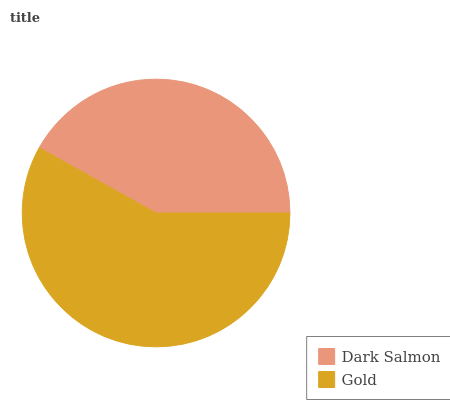Is Dark Salmon the minimum?
Answer yes or no. Yes. Is Gold the maximum?
Answer yes or no. Yes. Is Gold the minimum?
Answer yes or no. No. Is Gold greater than Dark Salmon?
Answer yes or no. Yes. Is Dark Salmon less than Gold?
Answer yes or no. Yes. Is Dark Salmon greater than Gold?
Answer yes or no. No. Is Gold less than Dark Salmon?
Answer yes or no. No. Is Gold the high median?
Answer yes or no. Yes. Is Dark Salmon the low median?
Answer yes or no. Yes. Is Dark Salmon the high median?
Answer yes or no. No. Is Gold the low median?
Answer yes or no. No. 